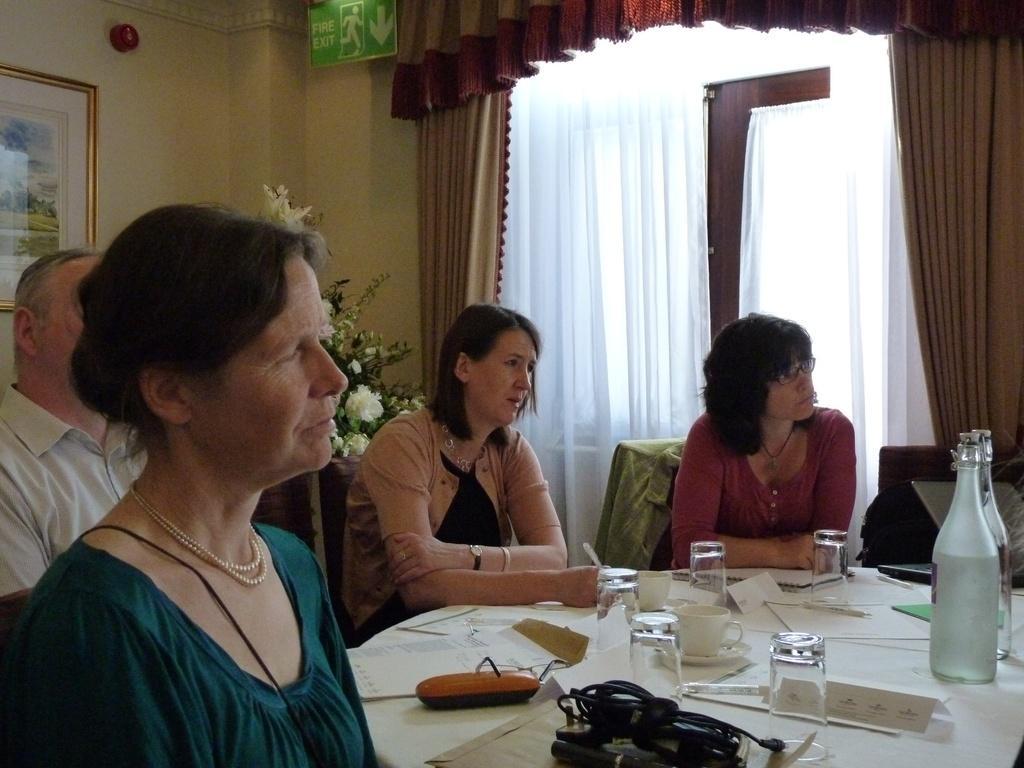How would you summarize this image in a sentence or two? In this image I can see few people are sitting on chairs. Here on this table I can see few bottles and few glasses. In the background I can see a plant, a frame on this wall and a curtain on this window. 